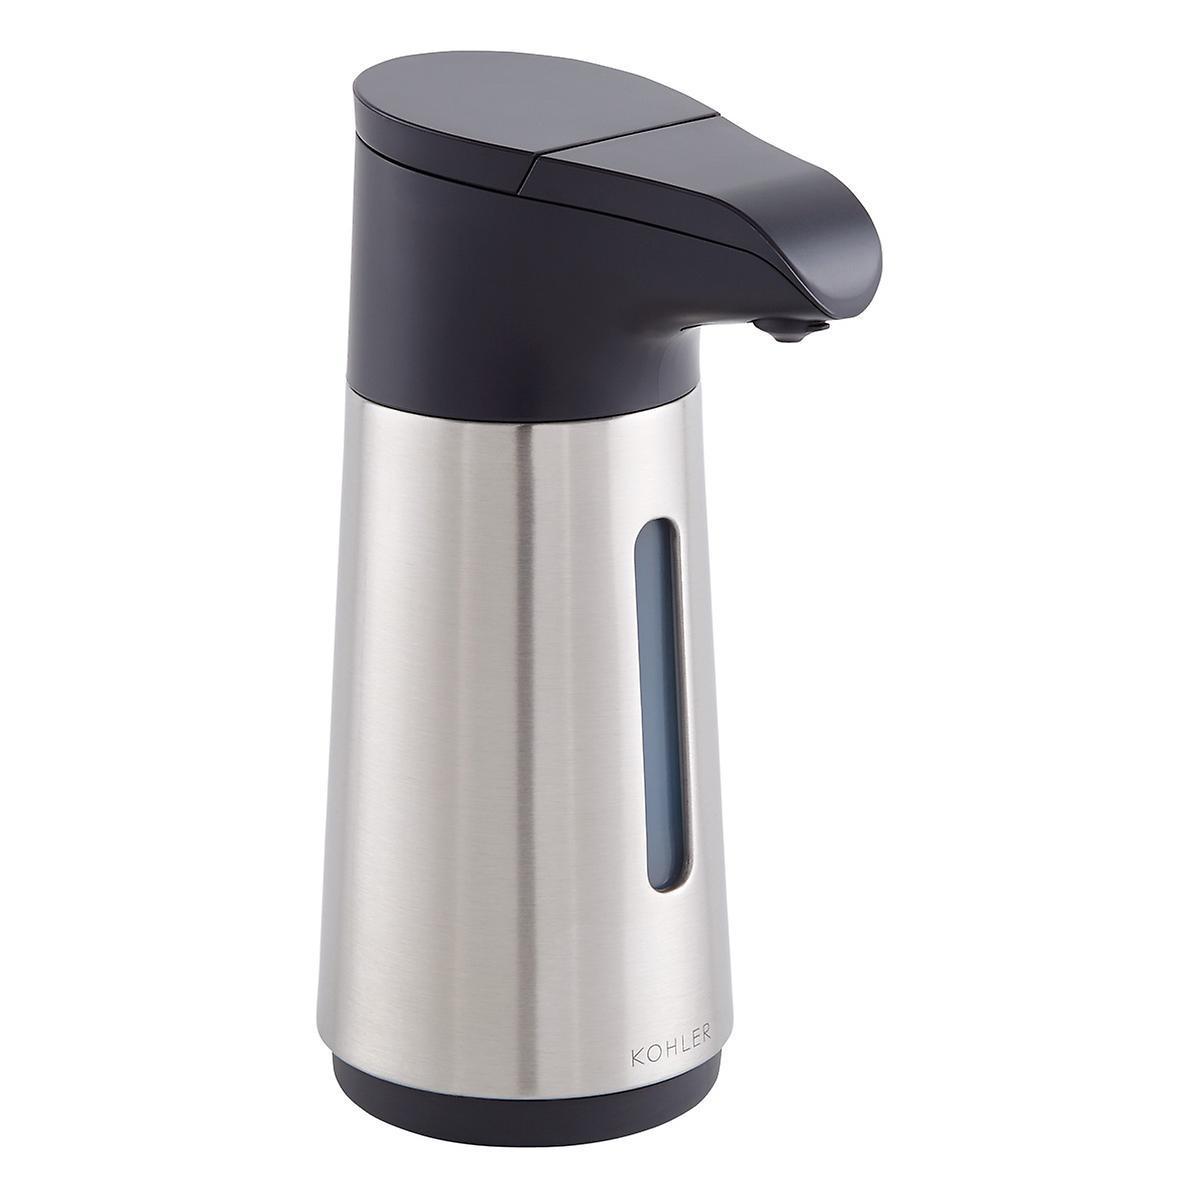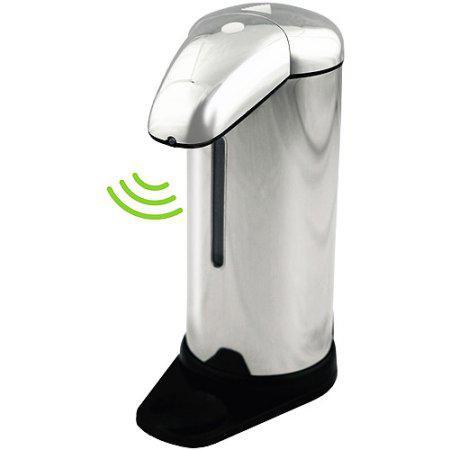The first image is the image on the left, the second image is the image on the right. For the images shown, is this caption "There is a hand in the image on the right" true? Answer yes or no. No. 